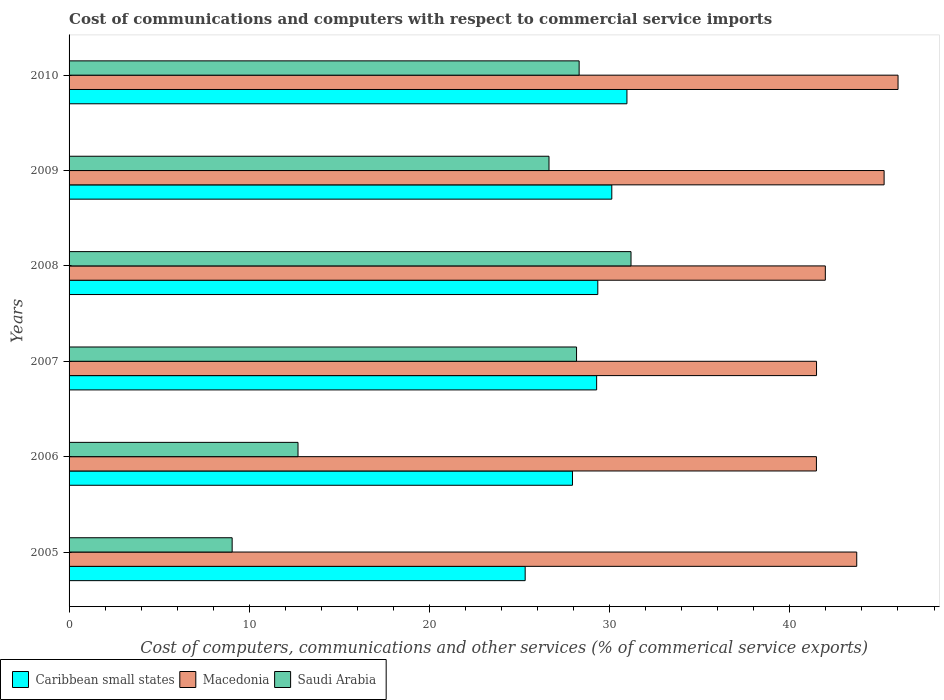How many different coloured bars are there?
Your response must be concise. 3. Are the number of bars per tick equal to the number of legend labels?
Ensure brevity in your answer.  Yes. In how many cases, is the number of bars for a given year not equal to the number of legend labels?
Give a very brief answer. 0. What is the cost of communications and computers in Macedonia in 2006?
Your response must be concise. 41.47. Across all years, what is the maximum cost of communications and computers in Saudi Arabia?
Make the answer very short. 31.19. Across all years, what is the minimum cost of communications and computers in Saudi Arabia?
Provide a succinct answer. 9.05. What is the total cost of communications and computers in Saudi Arabia in the graph?
Make the answer very short. 136.04. What is the difference between the cost of communications and computers in Caribbean small states in 2009 and that in 2010?
Offer a terse response. -0.84. What is the difference between the cost of communications and computers in Macedonia in 2006 and the cost of communications and computers in Saudi Arabia in 2007?
Your answer should be compact. 13.31. What is the average cost of communications and computers in Macedonia per year?
Your answer should be very brief. 43.31. In the year 2009, what is the difference between the cost of communications and computers in Caribbean small states and cost of communications and computers in Macedonia?
Ensure brevity in your answer.  -15.11. In how many years, is the cost of communications and computers in Macedonia greater than 38 %?
Give a very brief answer. 6. What is the ratio of the cost of communications and computers in Macedonia in 2008 to that in 2009?
Give a very brief answer. 0.93. Is the cost of communications and computers in Caribbean small states in 2007 less than that in 2008?
Your answer should be very brief. Yes. Is the difference between the cost of communications and computers in Caribbean small states in 2005 and 2007 greater than the difference between the cost of communications and computers in Macedonia in 2005 and 2007?
Make the answer very short. No. What is the difference between the highest and the second highest cost of communications and computers in Caribbean small states?
Make the answer very short. 0.84. What is the difference between the highest and the lowest cost of communications and computers in Macedonia?
Give a very brief answer. 4.53. What does the 3rd bar from the top in 2005 represents?
Keep it short and to the point. Caribbean small states. What does the 3rd bar from the bottom in 2010 represents?
Make the answer very short. Saudi Arabia. Is it the case that in every year, the sum of the cost of communications and computers in Macedonia and cost of communications and computers in Caribbean small states is greater than the cost of communications and computers in Saudi Arabia?
Provide a short and direct response. Yes. How many years are there in the graph?
Your response must be concise. 6. What is the difference between two consecutive major ticks on the X-axis?
Your answer should be very brief. 10. Does the graph contain any zero values?
Ensure brevity in your answer.  No. Does the graph contain grids?
Provide a short and direct response. No. Where does the legend appear in the graph?
Provide a short and direct response. Bottom left. How are the legend labels stacked?
Provide a short and direct response. Horizontal. What is the title of the graph?
Your answer should be compact. Cost of communications and computers with respect to commercial service imports. Does "Lower middle income" appear as one of the legend labels in the graph?
Ensure brevity in your answer.  No. What is the label or title of the X-axis?
Your response must be concise. Cost of computers, communications and other services (% of commerical service exports). What is the label or title of the Y-axis?
Your answer should be very brief. Years. What is the Cost of computers, communications and other services (% of commerical service exports) of Caribbean small states in 2005?
Ensure brevity in your answer.  25.31. What is the Cost of computers, communications and other services (% of commerical service exports) in Macedonia in 2005?
Make the answer very short. 43.71. What is the Cost of computers, communications and other services (% of commerical service exports) in Saudi Arabia in 2005?
Make the answer very short. 9.05. What is the Cost of computers, communications and other services (% of commerical service exports) of Caribbean small states in 2006?
Give a very brief answer. 27.94. What is the Cost of computers, communications and other services (% of commerical service exports) in Macedonia in 2006?
Provide a succinct answer. 41.47. What is the Cost of computers, communications and other services (% of commerical service exports) in Saudi Arabia in 2006?
Your response must be concise. 12.71. What is the Cost of computers, communications and other services (% of commerical service exports) in Caribbean small states in 2007?
Ensure brevity in your answer.  29.28. What is the Cost of computers, communications and other services (% of commerical service exports) in Macedonia in 2007?
Your response must be concise. 41.48. What is the Cost of computers, communications and other services (% of commerical service exports) in Saudi Arabia in 2007?
Offer a terse response. 28.16. What is the Cost of computers, communications and other services (% of commerical service exports) in Caribbean small states in 2008?
Offer a very short reply. 29.34. What is the Cost of computers, communications and other services (% of commerical service exports) in Macedonia in 2008?
Offer a very short reply. 41.97. What is the Cost of computers, communications and other services (% of commerical service exports) of Saudi Arabia in 2008?
Ensure brevity in your answer.  31.19. What is the Cost of computers, communications and other services (% of commerical service exports) of Caribbean small states in 2009?
Your answer should be very brief. 30.12. What is the Cost of computers, communications and other services (% of commerical service exports) in Macedonia in 2009?
Offer a terse response. 45.23. What is the Cost of computers, communications and other services (% of commerical service exports) of Saudi Arabia in 2009?
Provide a short and direct response. 26.63. What is the Cost of computers, communications and other services (% of commerical service exports) in Caribbean small states in 2010?
Provide a short and direct response. 30.96. What is the Cost of computers, communications and other services (% of commerical service exports) in Macedonia in 2010?
Give a very brief answer. 46. What is the Cost of computers, communications and other services (% of commerical service exports) of Saudi Arabia in 2010?
Your answer should be compact. 28.31. Across all years, what is the maximum Cost of computers, communications and other services (% of commerical service exports) of Caribbean small states?
Ensure brevity in your answer.  30.96. Across all years, what is the maximum Cost of computers, communications and other services (% of commerical service exports) of Macedonia?
Ensure brevity in your answer.  46. Across all years, what is the maximum Cost of computers, communications and other services (% of commerical service exports) of Saudi Arabia?
Your answer should be very brief. 31.19. Across all years, what is the minimum Cost of computers, communications and other services (% of commerical service exports) of Caribbean small states?
Your response must be concise. 25.31. Across all years, what is the minimum Cost of computers, communications and other services (% of commerical service exports) in Macedonia?
Provide a succinct answer. 41.47. Across all years, what is the minimum Cost of computers, communications and other services (% of commerical service exports) in Saudi Arabia?
Your answer should be compact. 9.05. What is the total Cost of computers, communications and other services (% of commerical service exports) in Caribbean small states in the graph?
Your answer should be compact. 172.94. What is the total Cost of computers, communications and other services (% of commerical service exports) in Macedonia in the graph?
Your answer should be compact. 259.87. What is the total Cost of computers, communications and other services (% of commerical service exports) in Saudi Arabia in the graph?
Offer a very short reply. 136.04. What is the difference between the Cost of computers, communications and other services (% of commerical service exports) in Caribbean small states in 2005 and that in 2006?
Keep it short and to the point. -2.63. What is the difference between the Cost of computers, communications and other services (% of commerical service exports) in Macedonia in 2005 and that in 2006?
Your response must be concise. 2.24. What is the difference between the Cost of computers, communications and other services (% of commerical service exports) in Saudi Arabia in 2005 and that in 2006?
Your answer should be compact. -3.65. What is the difference between the Cost of computers, communications and other services (% of commerical service exports) of Caribbean small states in 2005 and that in 2007?
Offer a terse response. -3.97. What is the difference between the Cost of computers, communications and other services (% of commerical service exports) of Macedonia in 2005 and that in 2007?
Ensure brevity in your answer.  2.23. What is the difference between the Cost of computers, communications and other services (% of commerical service exports) of Saudi Arabia in 2005 and that in 2007?
Provide a short and direct response. -19.11. What is the difference between the Cost of computers, communications and other services (% of commerical service exports) in Caribbean small states in 2005 and that in 2008?
Provide a short and direct response. -4.03. What is the difference between the Cost of computers, communications and other services (% of commerical service exports) in Macedonia in 2005 and that in 2008?
Your response must be concise. 1.74. What is the difference between the Cost of computers, communications and other services (% of commerical service exports) in Saudi Arabia in 2005 and that in 2008?
Your answer should be very brief. -22.14. What is the difference between the Cost of computers, communications and other services (% of commerical service exports) in Caribbean small states in 2005 and that in 2009?
Offer a terse response. -4.81. What is the difference between the Cost of computers, communications and other services (% of commerical service exports) in Macedonia in 2005 and that in 2009?
Your answer should be very brief. -1.52. What is the difference between the Cost of computers, communications and other services (% of commerical service exports) in Saudi Arabia in 2005 and that in 2009?
Your response must be concise. -17.58. What is the difference between the Cost of computers, communications and other services (% of commerical service exports) of Caribbean small states in 2005 and that in 2010?
Offer a terse response. -5.65. What is the difference between the Cost of computers, communications and other services (% of commerical service exports) in Macedonia in 2005 and that in 2010?
Keep it short and to the point. -2.29. What is the difference between the Cost of computers, communications and other services (% of commerical service exports) in Saudi Arabia in 2005 and that in 2010?
Ensure brevity in your answer.  -19.26. What is the difference between the Cost of computers, communications and other services (% of commerical service exports) of Caribbean small states in 2006 and that in 2007?
Offer a terse response. -1.34. What is the difference between the Cost of computers, communications and other services (% of commerical service exports) of Macedonia in 2006 and that in 2007?
Give a very brief answer. -0.01. What is the difference between the Cost of computers, communications and other services (% of commerical service exports) in Saudi Arabia in 2006 and that in 2007?
Give a very brief answer. -15.46. What is the difference between the Cost of computers, communications and other services (% of commerical service exports) of Caribbean small states in 2006 and that in 2008?
Your answer should be compact. -1.41. What is the difference between the Cost of computers, communications and other services (% of commerical service exports) in Macedonia in 2006 and that in 2008?
Provide a succinct answer. -0.49. What is the difference between the Cost of computers, communications and other services (% of commerical service exports) in Saudi Arabia in 2006 and that in 2008?
Keep it short and to the point. -18.48. What is the difference between the Cost of computers, communications and other services (% of commerical service exports) in Caribbean small states in 2006 and that in 2009?
Offer a very short reply. -2.18. What is the difference between the Cost of computers, communications and other services (% of commerical service exports) in Macedonia in 2006 and that in 2009?
Make the answer very short. -3.76. What is the difference between the Cost of computers, communications and other services (% of commerical service exports) in Saudi Arabia in 2006 and that in 2009?
Keep it short and to the point. -13.93. What is the difference between the Cost of computers, communications and other services (% of commerical service exports) of Caribbean small states in 2006 and that in 2010?
Offer a very short reply. -3.02. What is the difference between the Cost of computers, communications and other services (% of commerical service exports) of Macedonia in 2006 and that in 2010?
Your answer should be very brief. -4.53. What is the difference between the Cost of computers, communications and other services (% of commerical service exports) in Saudi Arabia in 2006 and that in 2010?
Keep it short and to the point. -15.6. What is the difference between the Cost of computers, communications and other services (% of commerical service exports) in Caribbean small states in 2007 and that in 2008?
Your response must be concise. -0.06. What is the difference between the Cost of computers, communications and other services (% of commerical service exports) of Macedonia in 2007 and that in 2008?
Provide a short and direct response. -0.49. What is the difference between the Cost of computers, communications and other services (% of commerical service exports) of Saudi Arabia in 2007 and that in 2008?
Offer a terse response. -3.02. What is the difference between the Cost of computers, communications and other services (% of commerical service exports) of Caribbean small states in 2007 and that in 2009?
Offer a very short reply. -0.84. What is the difference between the Cost of computers, communications and other services (% of commerical service exports) of Macedonia in 2007 and that in 2009?
Ensure brevity in your answer.  -3.75. What is the difference between the Cost of computers, communications and other services (% of commerical service exports) of Saudi Arabia in 2007 and that in 2009?
Offer a very short reply. 1.53. What is the difference between the Cost of computers, communications and other services (% of commerical service exports) in Caribbean small states in 2007 and that in 2010?
Your response must be concise. -1.68. What is the difference between the Cost of computers, communications and other services (% of commerical service exports) of Macedonia in 2007 and that in 2010?
Your response must be concise. -4.52. What is the difference between the Cost of computers, communications and other services (% of commerical service exports) in Saudi Arabia in 2007 and that in 2010?
Provide a succinct answer. -0.14. What is the difference between the Cost of computers, communications and other services (% of commerical service exports) in Caribbean small states in 2008 and that in 2009?
Your answer should be compact. -0.78. What is the difference between the Cost of computers, communications and other services (% of commerical service exports) in Macedonia in 2008 and that in 2009?
Offer a very short reply. -3.26. What is the difference between the Cost of computers, communications and other services (% of commerical service exports) in Saudi Arabia in 2008 and that in 2009?
Your response must be concise. 4.55. What is the difference between the Cost of computers, communications and other services (% of commerical service exports) in Caribbean small states in 2008 and that in 2010?
Ensure brevity in your answer.  -1.62. What is the difference between the Cost of computers, communications and other services (% of commerical service exports) of Macedonia in 2008 and that in 2010?
Your answer should be very brief. -4.03. What is the difference between the Cost of computers, communications and other services (% of commerical service exports) of Saudi Arabia in 2008 and that in 2010?
Your answer should be very brief. 2.88. What is the difference between the Cost of computers, communications and other services (% of commerical service exports) of Caribbean small states in 2009 and that in 2010?
Provide a succinct answer. -0.84. What is the difference between the Cost of computers, communications and other services (% of commerical service exports) of Macedonia in 2009 and that in 2010?
Your answer should be very brief. -0.77. What is the difference between the Cost of computers, communications and other services (% of commerical service exports) in Saudi Arabia in 2009 and that in 2010?
Keep it short and to the point. -1.67. What is the difference between the Cost of computers, communications and other services (% of commerical service exports) of Caribbean small states in 2005 and the Cost of computers, communications and other services (% of commerical service exports) of Macedonia in 2006?
Your response must be concise. -16.16. What is the difference between the Cost of computers, communications and other services (% of commerical service exports) in Caribbean small states in 2005 and the Cost of computers, communications and other services (% of commerical service exports) in Saudi Arabia in 2006?
Your answer should be very brief. 12.61. What is the difference between the Cost of computers, communications and other services (% of commerical service exports) in Macedonia in 2005 and the Cost of computers, communications and other services (% of commerical service exports) in Saudi Arabia in 2006?
Provide a short and direct response. 31.01. What is the difference between the Cost of computers, communications and other services (% of commerical service exports) of Caribbean small states in 2005 and the Cost of computers, communications and other services (% of commerical service exports) of Macedonia in 2007?
Your answer should be compact. -16.17. What is the difference between the Cost of computers, communications and other services (% of commerical service exports) in Caribbean small states in 2005 and the Cost of computers, communications and other services (% of commerical service exports) in Saudi Arabia in 2007?
Your answer should be very brief. -2.85. What is the difference between the Cost of computers, communications and other services (% of commerical service exports) of Macedonia in 2005 and the Cost of computers, communications and other services (% of commerical service exports) of Saudi Arabia in 2007?
Make the answer very short. 15.55. What is the difference between the Cost of computers, communications and other services (% of commerical service exports) of Caribbean small states in 2005 and the Cost of computers, communications and other services (% of commerical service exports) of Macedonia in 2008?
Keep it short and to the point. -16.66. What is the difference between the Cost of computers, communications and other services (% of commerical service exports) of Caribbean small states in 2005 and the Cost of computers, communications and other services (% of commerical service exports) of Saudi Arabia in 2008?
Your answer should be very brief. -5.87. What is the difference between the Cost of computers, communications and other services (% of commerical service exports) in Macedonia in 2005 and the Cost of computers, communications and other services (% of commerical service exports) in Saudi Arabia in 2008?
Give a very brief answer. 12.53. What is the difference between the Cost of computers, communications and other services (% of commerical service exports) of Caribbean small states in 2005 and the Cost of computers, communications and other services (% of commerical service exports) of Macedonia in 2009?
Your answer should be very brief. -19.92. What is the difference between the Cost of computers, communications and other services (% of commerical service exports) in Caribbean small states in 2005 and the Cost of computers, communications and other services (% of commerical service exports) in Saudi Arabia in 2009?
Provide a succinct answer. -1.32. What is the difference between the Cost of computers, communications and other services (% of commerical service exports) of Macedonia in 2005 and the Cost of computers, communications and other services (% of commerical service exports) of Saudi Arabia in 2009?
Keep it short and to the point. 17.08. What is the difference between the Cost of computers, communications and other services (% of commerical service exports) of Caribbean small states in 2005 and the Cost of computers, communications and other services (% of commerical service exports) of Macedonia in 2010?
Your answer should be very brief. -20.69. What is the difference between the Cost of computers, communications and other services (% of commerical service exports) of Caribbean small states in 2005 and the Cost of computers, communications and other services (% of commerical service exports) of Saudi Arabia in 2010?
Keep it short and to the point. -3. What is the difference between the Cost of computers, communications and other services (% of commerical service exports) of Macedonia in 2005 and the Cost of computers, communications and other services (% of commerical service exports) of Saudi Arabia in 2010?
Your response must be concise. 15.41. What is the difference between the Cost of computers, communications and other services (% of commerical service exports) in Caribbean small states in 2006 and the Cost of computers, communications and other services (% of commerical service exports) in Macedonia in 2007?
Offer a terse response. -13.54. What is the difference between the Cost of computers, communications and other services (% of commerical service exports) in Caribbean small states in 2006 and the Cost of computers, communications and other services (% of commerical service exports) in Saudi Arabia in 2007?
Keep it short and to the point. -0.23. What is the difference between the Cost of computers, communications and other services (% of commerical service exports) in Macedonia in 2006 and the Cost of computers, communications and other services (% of commerical service exports) in Saudi Arabia in 2007?
Keep it short and to the point. 13.31. What is the difference between the Cost of computers, communications and other services (% of commerical service exports) of Caribbean small states in 2006 and the Cost of computers, communications and other services (% of commerical service exports) of Macedonia in 2008?
Give a very brief answer. -14.03. What is the difference between the Cost of computers, communications and other services (% of commerical service exports) in Caribbean small states in 2006 and the Cost of computers, communications and other services (% of commerical service exports) in Saudi Arabia in 2008?
Give a very brief answer. -3.25. What is the difference between the Cost of computers, communications and other services (% of commerical service exports) in Macedonia in 2006 and the Cost of computers, communications and other services (% of commerical service exports) in Saudi Arabia in 2008?
Your response must be concise. 10.29. What is the difference between the Cost of computers, communications and other services (% of commerical service exports) of Caribbean small states in 2006 and the Cost of computers, communications and other services (% of commerical service exports) of Macedonia in 2009?
Ensure brevity in your answer.  -17.29. What is the difference between the Cost of computers, communications and other services (% of commerical service exports) of Caribbean small states in 2006 and the Cost of computers, communications and other services (% of commerical service exports) of Saudi Arabia in 2009?
Make the answer very short. 1.3. What is the difference between the Cost of computers, communications and other services (% of commerical service exports) in Macedonia in 2006 and the Cost of computers, communications and other services (% of commerical service exports) in Saudi Arabia in 2009?
Your answer should be compact. 14.84. What is the difference between the Cost of computers, communications and other services (% of commerical service exports) of Caribbean small states in 2006 and the Cost of computers, communications and other services (% of commerical service exports) of Macedonia in 2010?
Your answer should be compact. -18.07. What is the difference between the Cost of computers, communications and other services (% of commerical service exports) of Caribbean small states in 2006 and the Cost of computers, communications and other services (% of commerical service exports) of Saudi Arabia in 2010?
Provide a succinct answer. -0.37. What is the difference between the Cost of computers, communications and other services (% of commerical service exports) of Macedonia in 2006 and the Cost of computers, communications and other services (% of commerical service exports) of Saudi Arabia in 2010?
Provide a succinct answer. 13.17. What is the difference between the Cost of computers, communications and other services (% of commerical service exports) in Caribbean small states in 2007 and the Cost of computers, communications and other services (% of commerical service exports) in Macedonia in 2008?
Provide a short and direct response. -12.69. What is the difference between the Cost of computers, communications and other services (% of commerical service exports) of Caribbean small states in 2007 and the Cost of computers, communications and other services (% of commerical service exports) of Saudi Arabia in 2008?
Keep it short and to the point. -1.91. What is the difference between the Cost of computers, communications and other services (% of commerical service exports) of Macedonia in 2007 and the Cost of computers, communications and other services (% of commerical service exports) of Saudi Arabia in 2008?
Offer a very short reply. 10.3. What is the difference between the Cost of computers, communications and other services (% of commerical service exports) in Caribbean small states in 2007 and the Cost of computers, communications and other services (% of commerical service exports) in Macedonia in 2009?
Provide a succinct answer. -15.95. What is the difference between the Cost of computers, communications and other services (% of commerical service exports) of Caribbean small states in 2007 and the Cost of computers, communications and other services (% of commerical service exports) of Saudi Arabia in 2009?
Provide a succinct answer. 2.64. What is the difference between the Cost of computers, communications and other services (% of commerical service exports) of Macedonia in 2007 and the Cost of computers, communications and other services (% of commerical service exports) of Saudi Arabia in 2009?
Ensure brevity in your answer.  14.85. What is the difference between the Cost of computers, communications and other services (% of commerical service exports) in Caribbean small states in 2007 and the Cost of computers, communications and other services (% of commerical service exports) in Macedonia in 2010?
Your answer should be very brief. -16.73. What is the difference between the Cost of computers, communications and other services (% of commerical service exports) in Caribbean small states in 2007 and the Cost of computers, communications and other services (% of commerical service exports) in Saudi Arabia in 2010?
Offer a terse response. 0.97. What is the difference between the Cost of computers, communications and other services (% of commerical service exports) of Macedonia in 2007 and the Cost of computers, communications and other services (% of commerical service exports) of Saudi Arabia in 2010?
Give a very brief answer. 13.17. What is the difference between the Cost of computers, communications and other services (% of commerical service exports) in Caribbean small states in 2008 and the Cost of computers, communications and other services (% of commerical service exports) in Macedonia in 2009?
Offer a terse response. -15.89. What is the difference between the Cost of computers, communications and other services (% of commerical service exports) of Caribbean small states in 2008 and the Cost of computers, communications and other services (% of commerical service exports) of Saudi Arabia in 2009?
Make the answer very short. 2.71. What is the difference between the Cost of computers, communications and other services (% of commerical service exports) of Macedonia in 2008 and the Cost of computers, communications and other services (% of commerical service exports) of Saudi Arabia in 2009?
Keep it short and to the point. 15.34. What is the difference between the Cost of computers, communications and other services (% of commerical service exports) in Caribbean small states in 2008 and the Cost of computers, communications and other services (% of commerical service exports) in Macedonia in 2010?
Keep it short and to the point. -16.66. What is the difference between the Cost of computers, communications and other services (% of commerical service exports) of Caribbean small states in 2008 and the Cost of computers, communications and other services (% of commerical service exports) of Saudi Arabia in 2010?
Give a very brief answer. 1.04. What is the difference between the Cost of computers, communications and other services (% of commerical service exports) in Macedonia in 2008 and the Cost of computers, communications and other services (% of commerical service exports) in Saudi Arabia in 2010?
Give a very brief answer. 13.66. What is the difference between the Cost of computers, communications and other services (% of commerical service exports) in Caribbean small states in 2009 and the Cost of computers, communications and other services (% of commerical service exports) in Macedonia in 2010?
Your response must be concise. -15.89. What is the difference between the Cost of computers, communications and other services (% of commerical service exports) in Caribbean small states in 2009 and the Cost of computers, communications and other services (% of commerical service exports) in Saudi Arabia in 2010?
Provide a succinct answer. 1.81. What is the difference between the Cost of computers, communications and other services (% of commerical service exports) of Macedonia in 2009 and the Cost of computers, communications and other services (% of commerical service exports) of Saudi Arabia in 2010?
Your answer should be compact. 16.92. What is the average Cost of computers, communications and other services (% of commerical service exports) in Caribbean small states per year?
Keep it short and to the point. 28.82. What is the average Cost of computers, communications and other services (% of commerical service exports) in Macedonia per year?
Provide a succinct answer. 43.31. What is the average Cost of computers, communications and other services (% of commerical service exports) in Saudi Arabia per year?
Your response must be concise. 22.67. In the year 2005, what is the difference between the Cost of computers, communications and other services (% of commerical service exports) of Caribbean small states and Cost of computers, communications and other services (% of commerical service exports) of Macedonia?
Make the answer very short. -18.4. In the year 2005, what is the difference between the Cost of computers, communications and other services (% of commerical service exports) in Caribbean small states and Cost of computers, communications and other services (% of commerical service exports) in Saudi Arabia?
Your response must be concise. 16.26. In the year 2005, what is the difference between the Cost of computers, communications and other services (% of commerical service exports) of Macedonia and Cost of computers, communications and other services (% of commerical service exports) of Saudi Arabia?
Give a very brief answer. 34.66. In the year 2006, what is the difference between the Cost of computers, communications and other services (% of commerical service exports) of Caribbean small states and Cost of computers, communications and other services (% of commerical service exports) of Macedonia?
Provide a short and direct response. -13.54. In the year 2006, what is the difference between the Cost of computers, communications and other services (% of commerical service exports) of Caribbean small states and Cost of computers, communications and other services (% of commerical service exports) of Saudi Arabia?
Provide a succinct answer. 15.23. In the year 2006, what is the difference between the Cost of computers, communications and other services (% of commerical service exports) of Macedonia and Cost of computers, communications and other services (% of commerical service exports) of Saudi Arabia?
Your answer should be compact. 28.77. In the year 2007, what is the difference between the Cost of computers, communications and other services (% of commerical service exports) of Caribbean small states and Cost of computers, communications and other services (% of commerical service exports) of Macedonia?
Your response must be concise. -12.2. In the year 2007, what is the difference between the Cost of computers, communications and other services (% of commerical service exports) of Caribbean small states and Cost of computers, communications and other services (% of commerical service exports) of Saudi Arabia?
Give a very brief answer. 1.11. In the year 2007, what is the difference between the Cost of computers, communications and other services (% of commerical service exports) of Macedonia and Cost of computers, communications and other services (% of commerical service exports) of Saudi Arabia?
Your response must be concise. 13.32. In the year 2008, what is the difference between the Cost of computers, communications and other services (% of commerical service exports) of Caribbean small states and Cost of computers, communications and other services (% of commerical service exports) of Macedonia?
Keep it short and to the point. -12.63. In the year 2008, what is the difference between the Cost of computers, communications and other services (% of commerical service exports) in Caribbean small states and Cost of computers, communications and other services (% of commerical service exports) in Saudi Arabia?
Offer a terse response. -1.84. In the year 2008, what is the difference between the Cost of computers, communications and other services (% of commerical service exports) in Macedonia and Cost of computers, communications and other services (% of commerical service exports) in Saudi Arabia?
Offer a very short reply. 10.78. In the year 2009, what is the difference between the Cost of computers, communications and other services (% of commerical service exports) of Caribbean small states and Cost of computers, communications and other services (% of commerical service exports) of Macedonia?
Provide a succinct answer. -15.11. In the year 2009, what is the difference between the Cost of computers, communications and other services (% of commerical service exports) in Caribbean small states and Cost of computers, communications and other services (% of commerical service exports) in Saudi Arabia?
Provide a succinct answer. 3.48. In the year 2009, what is the difference between the Cost of computers, communications and other services (% of commerical service exports) of Macedonia and Cost of computers, communications and other services (% of commerical service exports) of Saudi Arabia?
Your answer should be very brief. 18.6. In the year 2010, what is the difference between the Cost of computers, communications and other services (% of commerical service exports) of Caribbean small states and Cost of computers, communications and other services (% of commerical service exports) of Macedonia?
Ensure brevity in your answer.  -15.05. In the year 2010, what is the difference between the Cost of computers, communications and other services (% of commerical service exports) of Caribbean small states and Cost of computers, communications and other services (% of commerical service exports) of Saudi Arabia?
Offer a terse response. 2.65. In the year 2010, what is the difference between the Cost of computers, communications and other services (% of commerical service exports) of Macedonia and Cost of computers, communications and other services (% of commerical service exports) of Saudi Arabia?
Your response must be concise. 17.7. What is the ratio of the Cost of computers, communications and other services (% of commerical service exports) of Caribbean small states in 2005 to that in 2006?
Your answer should be compact. 0.91. What is the ratio of the Cost of computers, communications and other services (% of commerical service exports) in Macedonia in 2005 to that in 2006?
Offer a very short reply. 1.05. What is the ratio of the Cost of computers, communications and other services (% of commerical service exports) of Saudi Arabia in 2005 to that in 2006?
Keep it short and to the point. 0.71. What is the ratio of the Cost of computers, communications and other services (% of commerical service exports) in Caribbean small states in 2005 to that in 2007?
Give a very brief answer. 0.86. What is the ratio of the Cost of computers, communications and other services (% of commerical service exports) in Macedonia in 2005 to that in 2007?
Keep it short and to the point. 1.05. What is the ratio of the Cost of computers, communications and other services (% of commerical service exports) in Saudi Arabia in 2005 to that in 2007?
Your answer should be compact. 0.32. What is the ratio of the Cost of computers, communications and other services (% of commerical service exports) of Caribbean small states in 2005 to that in 2008?
Provide a succinct answer. 0.86. What is the ratio of the Cost of computers, communications and other services (% of commerical service exports) of Macedonia in 2005 to that in 2008?
Keep it short and to the point. 1.04. What is the ratio of the Cost of computers, communications and other services (% of commerical service exports) of Saudi Arabia in 2005 to that in 2008?
Make the answer very short. 0.29. What is the ratio of the Cost of computers, communications and other services (% of commerical service exports) in Caribbean small states in 2005 to that in 2009?
Give a very brief answer. 0.84. What is the ratio of the Cost of computers, communications and other services (% of commerical service exports) in Macedonia in 2005 to that in 2009?
Your answer should be very brief. 0.97. What is the ratio of the Cost of computers, communications and other services (% of commerical service exports) of Saudi Arabia in 2005 to that in 2009?
Make the answer very short. 0.34. What is the ratio of the Cost of computers, communications and other services (% of commerical service exports) in Caribbean small states in 2005 to that in 2010?
Provide a succinct answer. 0.82. What is the ratio of the Cost of computers, communications and other services (% of commerical service exports) in Macedonia in 2005 to that in 2010?
Keep it short and to the point. 0.95. What is the ratio of the Cost of computers, communications and other services (% of commerical service exports) in Saudi Arabia in 2005 to that in 2010?
Keep it short and to the point. 0.32. What is the ratio of the Cost of computers, communications and other services (% of commerical service exports) in Caribbean small states in 2006 to that in 2007?
Make the answer very short. 0.95. What is the ratio of the Cost of computers, communications and other services (% of commerical service exports) of Macedonia in 2006 to that in 2007?
Ensure brevity in your answer.  1. What is the ratio of the Cost of computers, communications and other services (% of commerical service exports) in Saudi Arabia in 2006 to that in 2007?
Ensure brevity in your answer.  0.45. What is the ratio of the Cost of computers, communications and other services (% of commerical service exports) of Caribbean small states in 2006 to that in 2008?
Provide a short and direct response. 0.95. What is the ratio of the Cost of computers, communications and other services (% of commerical service exports) of Saudi Arabia in 2006 to that in 2008?
Provide a succinct answer. 0.41. What is the ratio of the Cost of computers, communications and other services (% of commerical service exports) of Caribbean small states in 2006 to that in 2009?
Offer a terse response. 0.93. What is the ratio of the Cost of computers, communications and other services (% of commerical service exports) of Macedonia in 2006 to that in 2009?
Provide a short and direct response. 0.92. What is the ratio of the Cost of computers, communications and other services (% of commerical service exports) of Saudi Arabia in 2006 to that in 2009?
Your answer should be very brief. 0.48. What is the ratio of the Cost of computers, communications and other services (% of commerical service exports) in Caribbean small states in 2006 to that in 2010?
Offer a terse response. 0.9. What is the ratio of the Cost of computers, communications and other services (% of commerical service exports) in Macedonia in 2006 to that in 2010?
Ensure brevity in your answer.  0.9. What is the ratio of the Cost of computers, communications and other services (% of commerical service exports) in Saudi Arabia in 2006 to that in 2010?
Your answer should be compact. 0.45. What is the ratio of the Cost of computers, communications and other services (% of commerical service exports) of Caribbean small states in 2007 to that in 2008?
Provide a succinct answer. 1. What is the ratio of the Cost of computers, communications and other services (% of commerical service exports) of Macedonia in 2007 to that in 2008?
Ensure brevity in your answer.  0.99. What is the ratio of the Cost of computers, communications and other services (% of commerical service exports) in Saudi Arabia in 2007 to that in 2008?
Your answer should be very brief. 0.9. What is the ratio of the Cost of computers, communications and other services (% of commerical service exports) in Caribbean small states in 2007 to that in 2009?
Your answer should be very brief. 0.97. What is the ratio of the Cost of computers, communications and other services (% of commerical service exports) of Macedonia in 2007 to that in 2009?
Give a very brief answer. 0.92. What is the ratio of the Cost of computers, communications and other services (% of commerical service exports) in Saudi Arabia in 2007 to that in 2009?
Keep it short and to the point. 1.06. What is the ratio of the Cost of computers, communications and other services (% of commerical service exports) in Caribbean small states in 2007 to that in 2010?
Your response must be concise. 0.95. What is the ratio of the Cost of computers, communications and other services (% of commerical service exports) in Macedonia in 2007 to that in 2010?
Give a very brief answer. 0.9. What is the ratio of the Cost of computers, communications and other services (% of commerical service exports) of Saudi Arabia in 2007 to that in 2010?
Give a very brief answer. 0.99. What is the ratio of the Cost of computers, communications and other services (% of commerical service exports) in Caribbean small states in 2008 to that in 2009?
Your answer should be compact. 0.97. What is the ratio of the Cost of computers, communications and other services (% of commerical service exports) of Macedonia in 2008 to that in 2009?
Ensure brevity in your answer.  0.93. What is the ratio of the Cost of computers, communications and other services (% of commerical service exports) in Saudi Arabia in 2008 to that in 2009?
Ensure brevity in your answer.  1.17. What is the ratio of the Cost of computers, communications and other services (% of commerical service exports) of Caribbean small states in 2008 to that in 2010?
Offer a terse response. 0.95. What is the ratio of the Cost of computers, communications and other services (% of commerical service exports) of Macedonia in 2008 to that in 2010?
Make the answer very short. 0.91. What is the ratio of the Cost of computers, communications and other services (% of commerical service exports) in Saudi Arabia in 2008 to that in 2010?
Your answer should be very brief. 1.1. What is the ratio of the Cost of computers, communications and other services (% of commerical service exports) in Caribbean small states in 2009 to that in 2010?
Your answer should be very brief. 0.97. What is the ratio of the Cost of computers, communications and other services (% of commerical service exports) in Macedonia in 2009 to that in 2010?
Offer a terse response. 0.98. What is the ratio of the Cost of computers, communications and other services (% of commerical service exports) of Saudi Arabia in 2009 to that in 2010?
Your answer should be very brief. 0.94. What is the difference between the highest and the second highest Cost of computers, communications and other services (% of commerical service exports) in Caribbean small states?
Offer a very short reply. 0.84. What is the difference between the highest and the second highest Cost of computers, communications and other services (% of commerical service exports) of Macedonia?
Offer a very short reply. 0.77. What is the difference between the highest and the second highest Cost of computers, communications and other services (% of commerical service exports) of Saudi Arabia?
Ensure brevity in your answer.  2.88. What is the difference between the highest and the lowest Cost of computers, communications and other services (% of commerical service exports) in Caribbean small states?
Give a very brief answer. 5.65. What is the difference between the highest and the lowest Cost of computers, communications and other services (% of commerical service exports) of Macedonia?
Give a very brief answer. 4.53. What is the difference between the highest and the lowest Cost of computers, communications and other services (% of commerical service exports) of Saudi Arabia?
Give a very brief answer. 22.14. 